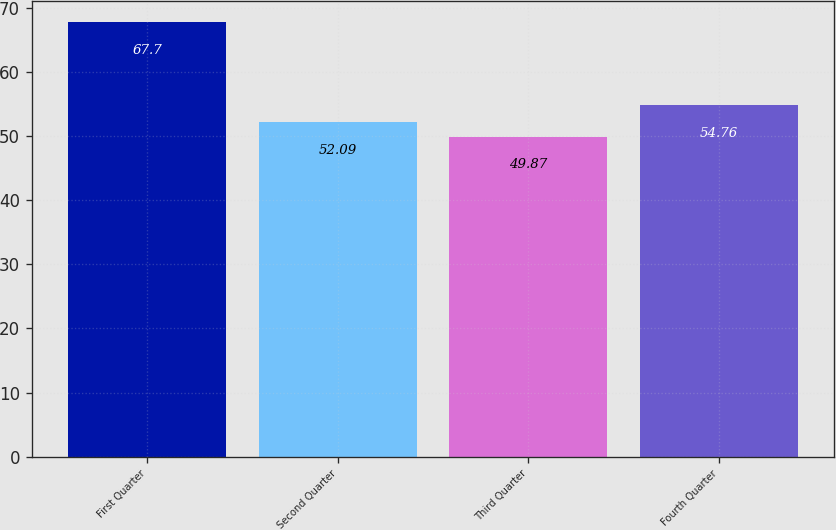Convert chart to OTSL. <chart><loc_0><loc_0><loc_500><loc_500><bar_chart><fcel>First Quarter<fcel>Second Quarter<fcel>Third Quarter<fcel>Fourth Quarter<nl><fcel>67.7<fcel>52.09<fcel>49.87<fcel>54.76<nl></chart> 